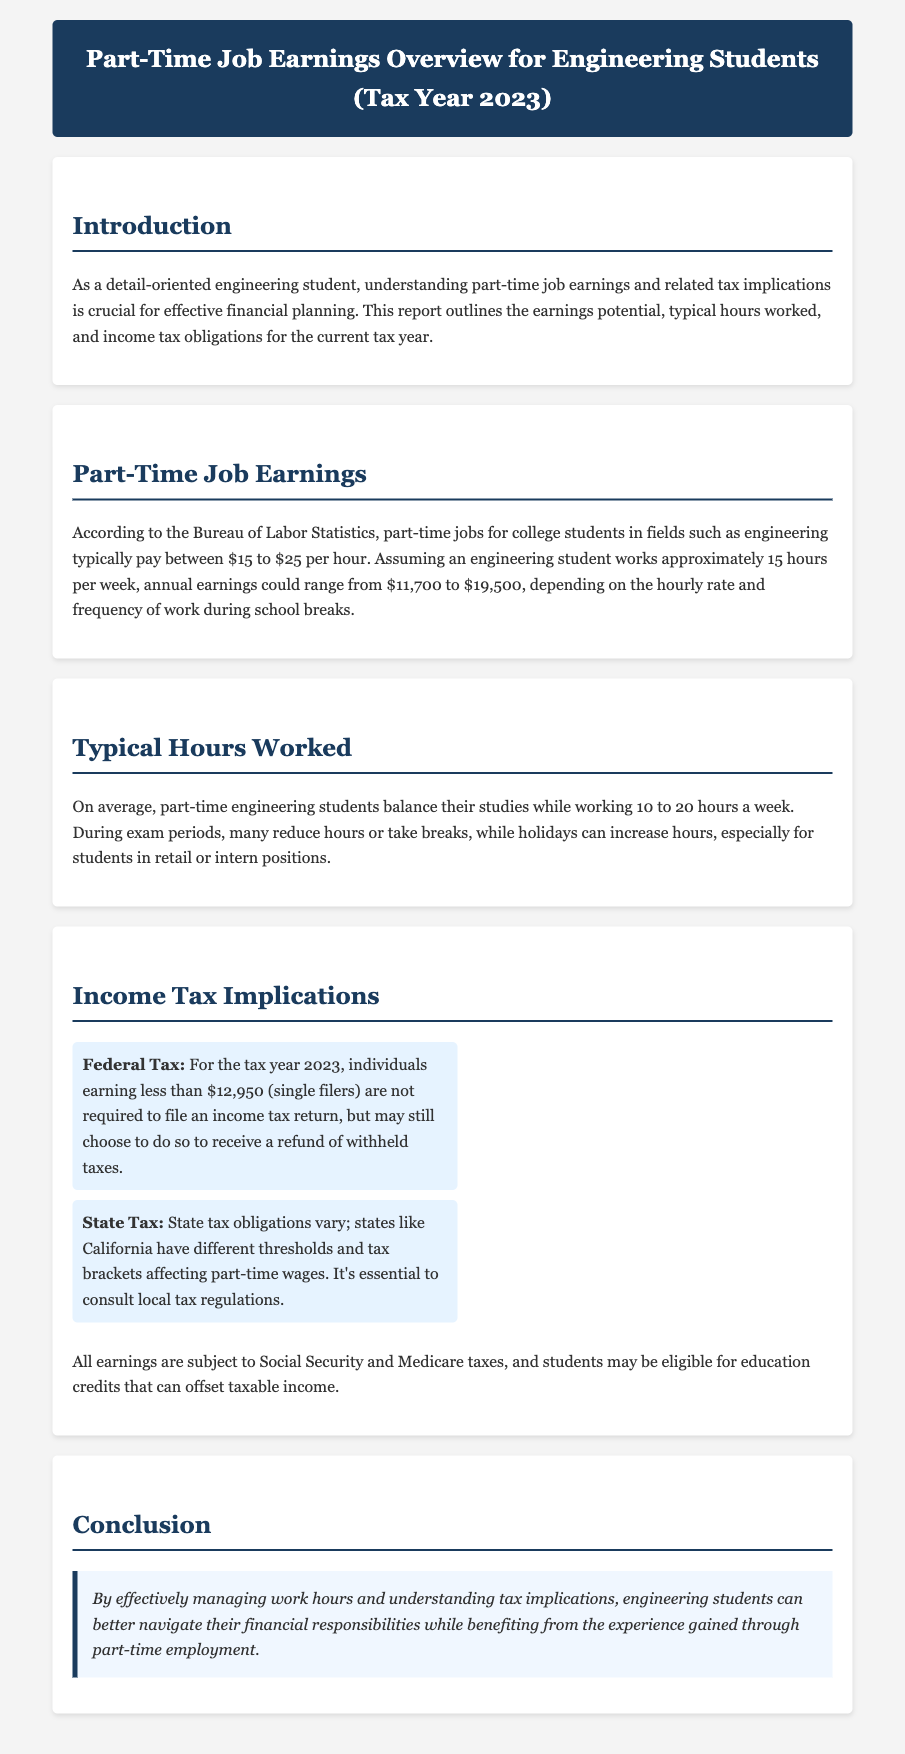What is the typical hourly pay range for part-time jobs? The document states that part-time jobs for college students in engineering typically pay between $15 to $25 per hour.
Answer: $15 to $25 How many hours do engineering students typically work per week? According to the document, part-time engineering students balance their studies while working 10 to 20 hours a week.
Answer: 10 to 20 hours What is the annual earnings range for a student working 15 hours per week? The document mentions that annual earnings could range from $11,700 to $19,500, depending on the hourly rate and frequency of work.
Answer: $11,700 to $19,500 What is the federal tax filing requirement threshold for single filers? The federal tax filing requirement for the tax year 2023 is for individuals earning less than $12,950.
Answer: $12,950 What can affect state tax obligations? The document notes that state tax obligations vary, and states have different thresholds and tax brackets affecting part-time wages.
Answer: State regulations What are students eligible for that can offset taxable income? According to the document, students may be eligible for education credits that can offset taxable income.
Answer: Education credits What might happen to work hours during exam periods? The document states that during exam periods, many students reduce hours or take breaks.
Answer: Reduce hours What type of jobs might increase hours during holidays? The document mentions that hours might increase for students in retail or intern positions during holidays.
Answer: Retail or intern positions What should students consider for effective financial planning? The document emphasizes understanding part-time job earnings and related tax implications.
Answer: Tax implications 